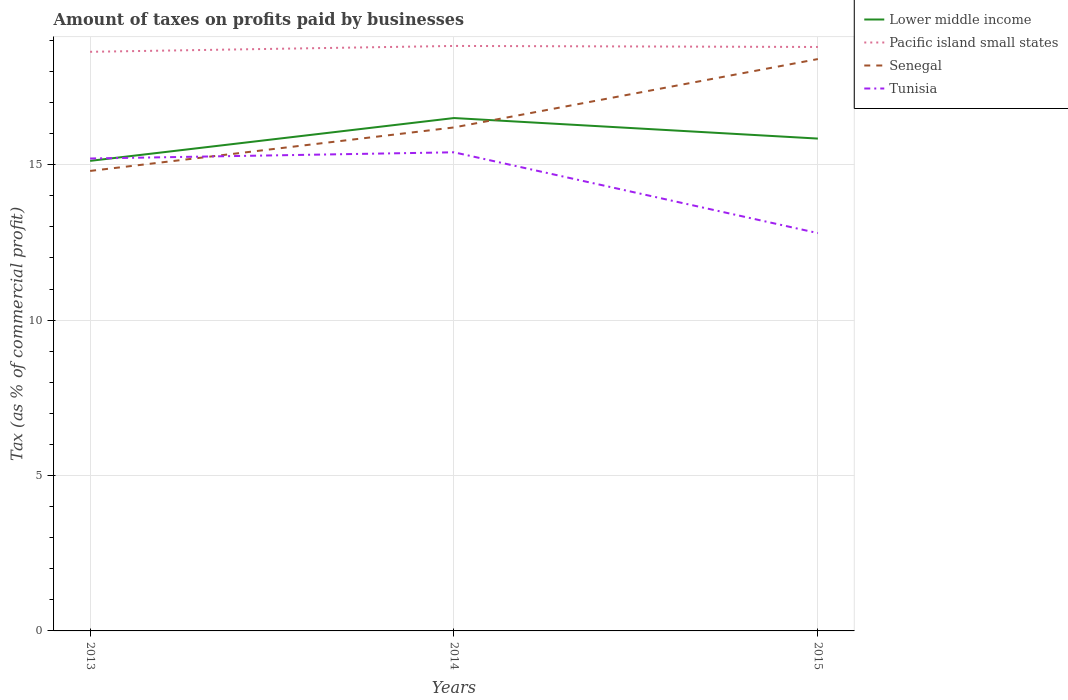How many different coloured lines are there?
Give a very brief answer. 4. In which year was the percentage of taxes paid by businesses in Senegal maximum?
Your response must be concise. 2013. What is the total percentage of taxes paid by businesses in Tunisia in the graph?
Your response must be concise. -0.2. What is the difference between the highest and the second highest percentage of taxes paid by businesses in Lower middle income?
Provide a succinct answer. 1.38. How many years are there in the graph?
Provide a short and direct response. 3. What is the difference between two consecutive major ticks on the Y-axis?
Provide a succinct answer. 5. Does the graph contain any zero values?
Ensure brevity in your answer.  No. How are the legend labels stacked?
Ensure brevity in your answer.  Vertical. What is the title of the graph?
Offer a very short reply. Amount of taxes on profits paid by businesses. Does "Central Europe" appear as one of the legend labels in the graph?
Offer a terse response. No. What is the label or title of the X-axis?
Provide a short and direct response. Years. What is the label or title of the Y-axis?
Provide a short and direct response. Tax (as % of commercial profit). What is the Tax (as % of commercial profit) in Lower middle income in 2013?
Your answer should be compact. 15.12. What is the Tax (as % of commercial profit) in Pacific island small states in 2013?
Your answer should be compact. 18.63. What is the Tax (as % of commercial profit) of Senegal in 2013?
Give a very brief answer. 14.8. What is the Tax (as % of commercial profit) in Tunisia in 2013?
Your response must be concise. 15.2. What is the Tax (as % of commercial profit) of Lower middle income in 2014?
Provide a succinct answer. 16.5. What is the Tax (as % of commercial profit) of Pacific island small states in 2014?
Offer a very short reply. 18.82. What is the Tax (as % of commercial profit) in Lower middle income in 2015?
Give a very brief answer. 15.84. What is the Tax (as % of commercial profit) of Pacific island small states in 2015?
Ensure brevity in your answer.  18.79. Across all years, what is the maximum Tax (as % of commercial profit) of Lower middle income?
Keep it short and to the point. 16.5. Across all years, what is the maximum Tax (as % of commercial profit) in Pacific island small states?
Offer a terse response. 18.82. Across all years, what is the maximum Tax (as % of commercial profit) in Senegal?
Ensure brevity in your answer.  18.4. Across all years, what is the minimum Tax (as % of commercial profit) of Lower middle income?
Your response must be concise. 15.12. Across all years, what is the minimum Tax (as % of commercial profit) of Pacific island small states?
Ensure brevity in your answer.  18.63. What is the total Tax (as % of commercial profit) in Lower middle income in the graph?
Offer a terse response. 47.47. What is the total Tax (as % of commercial profit) in Pacific island small states in the graph?
Offer a very short reply. 56.24. What is the total Tax (as % of commercial profit) in Senegal in the graph?
Your response must be concise. 49.4. What is the total Tax (as % of commercial profit) of Tunisia in the graph?
Your response must be concise. 43.4. What is the difference between the Tax (as % of commercial profit) in Lower middle income in 2013 and that in 2014?
Keep it short and to the point. -1.38. What is the difference between the Tax (as % of commercial profit) of Pacific island small states in 2013 and that in 2014?
Keep it short and to the point. -0.19. What is the difference between the Tax (as % of commercial profit) of Senegal in 2013 and that in 2014?
Your answer should be compact. -1.4. What is the difference between the Tax (as % of commercial profit) in Tunisia in 2013 and that in 2014?
Your response must be concise. -0.2. What is the difference between the Tax (as % of commercial profit) in Lower middle income in 2013 and that in 2015?
Provide a short and direct response. -0.72. What is the difference between the Tax (as % of commercial profit) in Pacific island small states in 2013 and that in 2015?
Your answer should be compact. -0.16. What is the difference between the Tax (as % of commercial profit) of Senegal in 2013 and that in 2015?
Give a very brief answer. -3.6. What is the difference between the Tax (as % of commercial profit) in Lower middle income in 2014 and that in 2015?
Ensure brevity in your answer.  0.66. What is the difference between the Tax (as % of commercial profit) in Lower middle income in 2013 and the Tax (as % of commercial profit) in Pacific island small states in 2014?
Offer a terse response. -3.7. What is the difference between the Tax (as % of commercial profit) in Lower middle income in 2013 and the Tax (as % of commercial profit) in Senegal in 2014?
Provide a short and direct response. -1.08. What is the difference between the Tax (as % of commercial profit) in Lower middle income in 2013 and the Tax (as % of commercial profit) in Tunisia in 2014?
Give a very brief answer. -0.28. What is the difference between the Tax (as % of commercial profit) of Pacific island small states in 2013 and the Tax (as % of commercial profit) of Senegal in 2014?
Your response must be concise. 2.43. What is the difference between the Tax (as % of commercial profit) of Pacific island small states in 2013 and the Tax (as % of commercial profit) of Tunisia in 2014?
Offer a very short reply. 3.23. What is the difference between the Tax (as % of commercial profit) in Lower middle income in 2013 and the Tax (as % of commercial profit) in Pacific island small states in 2015?
Your answer should be very brief. -3.66. What is the difference between the Tax (as % of commercial profit) of Lower middle income in 2013 and the Tax (as % of commercial profit) of Senegal in 2015?
Your response must be concise. -3.28. What is the difference between the Tax (as % of commercial profit) of Lower middle income in 2013 and the Tax (as % of commercial profit) of Tunisia in 2015?
Keep it short and to the point. 2.32. What is the difference between the Tax (as % of commercial profit) in Pacific island small states in 2013 and the Tax (as % of commercial profit) in Senegal in 2015?
Your response must be concise. 0.23. What is the difference between the Tax (as % of commercial profit) of Pacific island small states in 2013 and the Tax (as % of commercial profit) of Tunisia in 2015?
Provide a succinct answer. 5.83. What is the difference between the Tax (as % of commercial profit) of Senegal in 2013 and the Tax (as % of commercial profit) of Tunisia in 2015?
Offer a terse response. 2. What is the difference between the Tax (as % of commercial profit) in Lower middle income in 2014 and the Tax (as % of commercial profit) in Pacific island small states in 2015?
Provide a succinct answer. -2.29. What is the difference between the Tax (as % of commercial profit) in Lower middle income in 2014 and the Tax (as % of commercial profit) in Senegal in 2015?
Your answer should be very brief. -1.9. What is the difference between the Tax (as % of commercial profit) in Lower middle income in 2014 and the Tax (as % of commercial profit) in Tunisia in 2015?
Keep it short and to the point. 3.7. What is the difference between the Tax (as % of commercial profit) in Pacific island small states in 2014 and the Tax (as % of commercial profit) in Senegal in 2015?
Make the answer very short. 0.42. What is the difference between the Tax (as % of commercial profit) in Pacific island small states in 2014 and the Tax (as % of commercial profit) in Tunisia in 2015?
Give a very brief answer. 6.02. What is the difference between the Tax (as % of commercial profit) of Senegal in 2014 and the Tax (as % of commercial profit) of Tunisia in 2015?
Keep it short and to the point. 3.4. What is the average Tax (as % of commercial profit) of Lower middle income per year?
Give a very brief answer. 15.82. What is the average Tax (as % of commercial profit) of Pacific island small states per year?
Provide a short and direct response. 18.75. What is the average Tax (as % of commercial profit) in Senegal per year?
Your answer should be very brief. 16.47. What is the average Tax (as % of commercial profit) in Tunisia per year?
Offer a terse response. 14.47. In the year 2013, what is the difference between the Tax (as % of commercial profit) of Lower middle income and Tax (as % of commercial profit) of Pacific island small states?
Provide a short and direct response. -3.51. In the year 2013, what is the difference between the Tax (as % of commercial profit) in Lower middle income and Tax (as % of commercial profit) in Senegal?
Make the answer very short. 0.32. In the year 2013, what is the difference between the Tax (as % of commercial profit) in Lower middle income and Tax (as % of commercial profit) in Tunisia?
Make the answer very short. -0.08. In the year 2013, what is the difference between the Tax (as % of commercial profit) of Pacific island small states and Tax (as % of commercial profit) of Senegal?
Offer a very short reply. 3.83. In the year 2013, what is the difference between the Tax (as % of commercial profit) of Pacific island small states and Tax (as % of commercial profit) of Tunisia?
Provide a short and direct response. 3.43. In the year 2014, what is the difference between the Tax (as % of commercial profit) of Lower middle income and Tax (as % of commercial profit) of Pacific island small states?
Your answer should be very brief. -2.32. In the year 2014, what is the difference between the Tax (as % of commercial profit) in Lower middle income and Tax (as % of commercial profit) in Senegal?
Your answer should be compact. 0.3. In the year 2014, what is the difference between the Tax (as % of commercial profit) in Lower middle income and Tax (as % of commercial profit) in Tunisia?
Provide a short and direct response. 1.1. In the year 2014, what is the difference between the Tax (as % of commercial profit) in Pacific island small states and Tax (as % of commercial profit) in Senegal?
Ensure brevity in your answer.  2.62. In the year 2014, what is the difference between the Tax (as % of commercial profit) in Pacific island small states and Tax (as % of commercial profit) in Tunisia?
Offer a terse response. 3.42. In the year 2014, what is the difference between the Tax (as % of commercial profit) of Senegal and Tax (as % of commercial profit) of Tunisia?
Your answer should be very brief. 0.8. In the year 2015, what is the difference between the Tax (as % of commercial profit) in Lower middle income and Tax (as % of commercial profit) in Pacific island small states?
Offer a very short reply. -2.95. In the year 2015, what is the difference between the Tax (as % of commercial profit) of Lower middle income and Tax (as % of commercial profit) of Senegal?
Offer a terse response. -2.56. In the year 2015, what is the difference between the Tax (as % of commercial profit) in Lower middle income and Tax (as % of commercial profit) in Tunisia?
Keep it short and to the point. 3.04. In the year 2015, what is the difference between the Tax (as % of commercial profit) of Pacific island small states and Tax (as % of commercial profit) of Senegal?
Ensure brevity in your answer.  0.39. In the year 2015, what is the difference between the Tax (as % of commercial profit) in Pacific island small states and Tax (as % of commercial profit) in Tunisia?
Make the answer very short. 5.99. In the year 2015, what is the difference between the Tax (as % of commercial profit) in Senegal and Tax (as % of commercial profit) in Tunisia?
Make the answer very short. 5.6. What is the ratio of the Tax (as % of commercial profit) in Lower middle income in 2013 to that in 2014?
Your answer should be compact. 0.92. What is the ratio of the Tax (as % of commercial profit) in Pacific island small states in 2013 to that in 2014?
Provide a short and direct response. 0.99. What is the ratio of the Tax (as % of commercial profit) in Senegal in 2013 to that in 2014?
Keep it short and to the point. 0.91. What is the ratio of the Tax (as % of commercial profit) of Tunisia in 2013 to that in 2014?
Ensure brevity in your answer.  0.99. What is the ratio of the Tax (as % of commercial profit) in Lower middle income in 2013 to that in 2015?
Provide a short and direct response. 0.95. What is the ratio of the Tax (as % of commercial profit) in Pacific island small states in 2013 to that in 2015?
Offer a very short reply. 0.99. What is the ratio of the Tax (as % of commercial profit) of Senegal in 2013 to that in 2015?
Keep it short and to the point. 0.8. What is the ratio of the Tax (as % of commercial profit) of Tunisia in 2013 to that in 2015?
Provide a succinct answer. 1.19. What is the ratio of the Tax (as % of commercial profit) of Lower middle income in 2014 to that in 2015?
Your answer should be compact. 1.04. What is the ratio of the Tax (as % of commercial profit) in Pacific island small states in 2014 to that in 2015?
Your answer should be very brief. 1. What is the ratio of the Tax (as % of commercial profit) in Senegal in 2014 to that in 2015?
Give a very brief answer. 0.88. What is the ratio of the Tax (as % of commercial profit) in Tunisia in 2014 to that in 2015?
Offer a terse response. 1.2. What is the difference between the highest and the second highest Tax (as % of commercial profit) of Lower middle income?
Your answer should be very brief. 0.66. What is the difference between the highest and the lowest Tax (as % of commercial profit) of Lower middle income?
Your answer should be compact. 1.38. What is the difference between the highest and the lowest Tax (as % of commercial profit) in Pacific island small states?
Provide a short and direct response. 0.19. What is the difference between the highest and the lowest Tax (as % of commercial profit) of Senegal?
Provide a short and direct response. 3.6. 